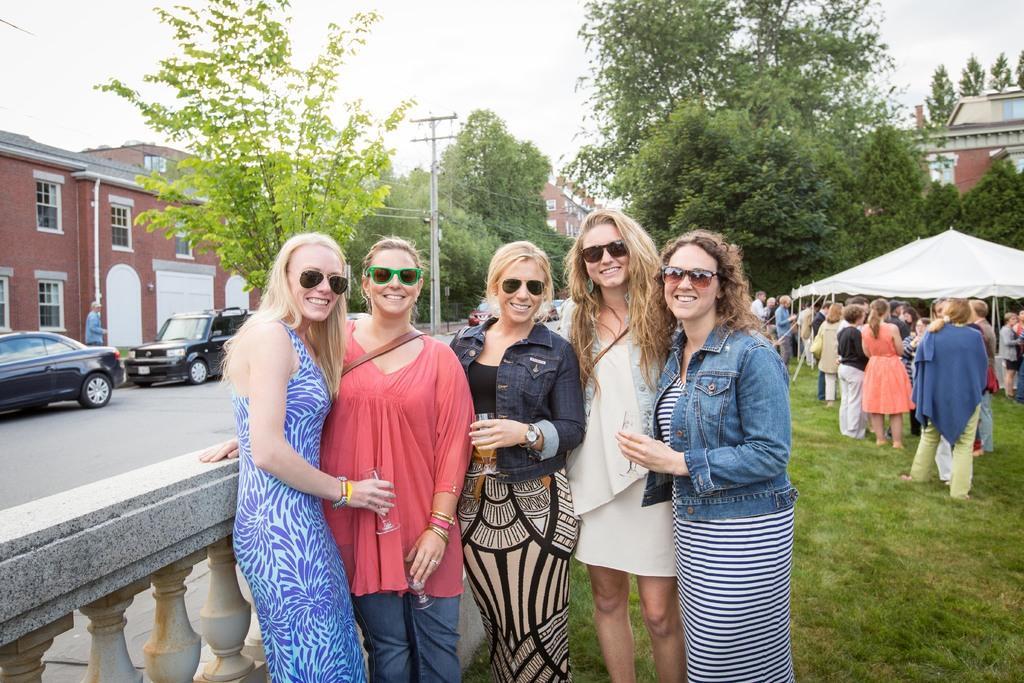How would you summarize this image in a sentence or two? In the picture I can see five woman standing and wearing goggles where four among them are holding a glass of drink in their hand and there are few other persons standing on a greenery ground and there are few trees,tents and a building in the right corner and there are few vehicles,buildings and trees in the background. 